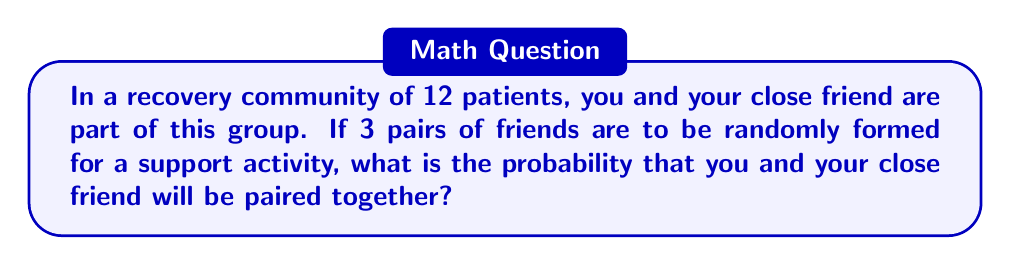Teach me how to tackle this problem. Let's approach this step-by-step:

1) First, we need to calculate the total number of ways to form 3 pairs from 12 people. This can be done using the following formula:

   $$\text{Total ways} = \frac{12!}{(2!)^3(12-2\cdot3)!} = \frac{12!}{8\cdot6!}$$

2) Now, let's calculate this:
   $$\frac{12\cdot11\cdot10\cdot9\cdot8\cdot7}{8} = 7,425$$

3) Next, we need to calculate the number of ways where you and your friend are paired together. In this case:
   - You and your friend are already paired (1 way)
   - We need to form 2 more pairs from the remaining 10 people

4) The number of ways to form 2 pairs from 10 people is:
   $$\frac{10!}{(2!)^2(10-2\cdot2)!} = \frac{10!}{4\cdot6!} = 945$$

5) Therefore, the probability is:
   $$P(\text{you and your friend paired}) = \frac{\text{Favorable outcomes}}{\text{Total outcomes}} = \frac{945}{7,425}$$

6) Simplifying this fraction:
   $$\frac{945}{7,425} = \frac{63}{495} = \frac{9}{71}$$
Answer: $\frac{9}{71}$ or approximately 0.1268 (12.68%) 